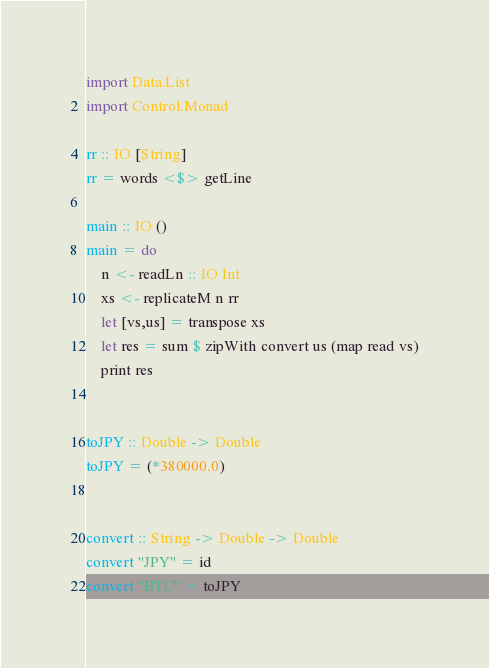<code> <loc_0><loc_0><loc_500><loc_500><_Haskell_>import Data.List
import Control.Monad

rr :: IO [String]
rr = words <$> getLine

main :: IO ()
main = do
    n <- readLn :: IO Int
    xs <- replicateM n rr
    let [vs,us] = transpose xs
    let res = sum $ zipWith convert us (map read vs)
    print res


toJPY :: Double -> Double
toJPY = (*380000.0)


convert :: String -> Double -> Double
convert "JPY" = id
convert "BTC" = toJPY
</code> 